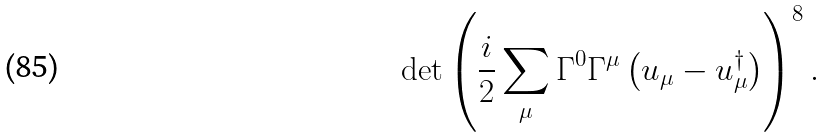Convert formula to latex. <formula><loc_0><loc_0><loc_500><loc_500>\det \left ( \frac { i } { 2 } \sum _ { \mu } \Gamma ^ { 0 } \Gamma ^ { \mu } \left ( u _ { \mu } - u _ { \mu } ^ { \dagger } \right ) \right ) ^ { 8 } .</formula> 